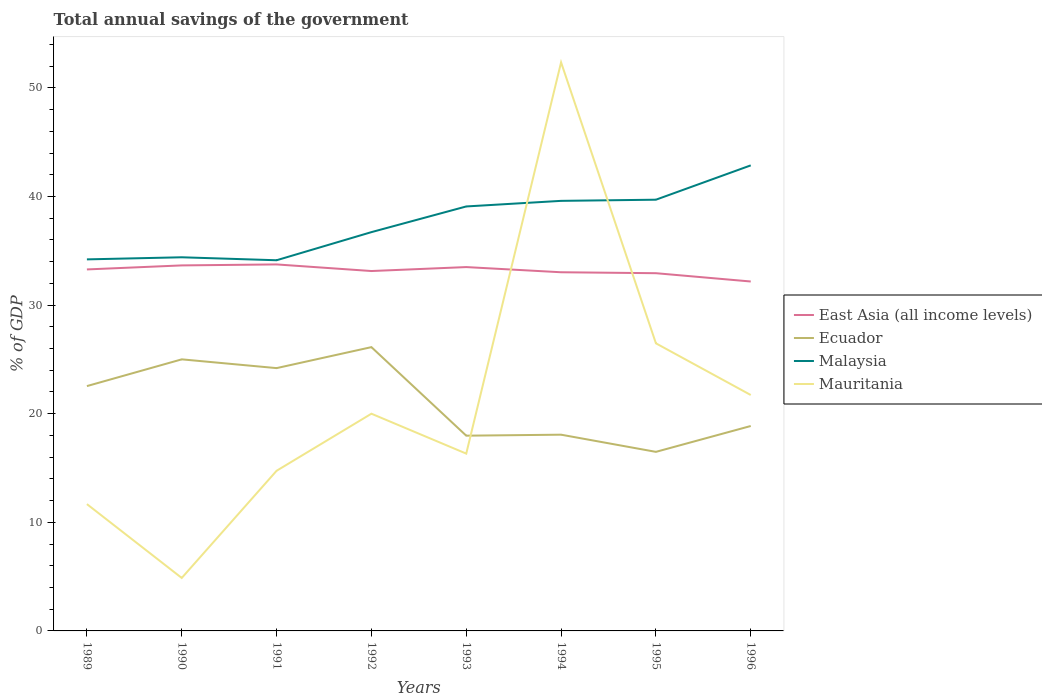How many different coloured lines are there?
Ensure brevity in your answer.  4. Does the line corresponding to Ecuador intersect with the line corresponding to Mauritania?
Offer a very short reply. Yes. Is the number of lines equal to the number of legend labels?
Provide a succinct answer. Yes. Across all years, what is the maximum total annual savings of the government in Malaysia?
Your answer should be very brief. 34.13. In which year was the total annual savings of the government in Malaysia maximum?
Ensure brevity in your answer.  1991. What is the total total annual savings of the government in Mauritania in the graph?
Give a very brief answer. 3.67. What is the difference between the highest and the second highest total annual savings of the government in Ecuador?
Your response must be concise. 9.64. What is the difference between the highest and the lowest total annual savings of the government in East Asia (all income levels)?
Your response must be concise. 4. Is the total annual savings of the government in Malaysia strictly greater than the total annual savings of the government in Ecuador over the years?
Offer a very short reply. No. How many lines are there?
Keep it short and to the point. 4. Where does the legend appear in the graph?
Provide a short and direct response. Center right. How many legend labels are there?
Offer a terse response. 4. How are the legend labels stacked?
Give a very brief answer. Vertical. What is the title of the graph?
Offer a very short reply. Total annual savings of the government. Does "Oman" appear as one of the legend labels in the graph?
Keep it short and to the point. No. What is the label or title of the X-axis?
Your response must be concise. Years. What is the label or title of the Y-axis?
Keep it short and to the point. % of GDP. What is the % of GDP of East Asia (all income levels) in 1989?
Keep it short and to the point. 33.29. What is the % of GDP in Ecuador in 1989?
Give a very brief answer. 22.54. What is the % of GDP of Malaysia in 1989?
Your answer should be very brief. 34.21. What is the % of GDP of Mauritania in 1989?
Offer a very short reply. 11.68. What is the % of GDP of East Asia (all income levels) in 1990?
Ensure brevity in your answer.  33.66. What is the % of GDP of Ecuador in 1990?
Give a very brief answer. 25.01. What is the % of GDP of Malaysia in 1990?
Make the answer very short. 34.4. What is the % of GDP of Mauritania in 1990?
Provide a succinct answer. 4.88. What is the % of GDP of East Asia (all income levels) in 1991?
Keep it short and to the point. 33.75. What is the % of GDP of Ecuador in 1991?
Your answer should be very brief. 24.2. What is the % of GDP in Malaysia in 1991?
Your answer should be compact. 34.13. What is the % of GDP of Mauritania in 1991?
Give a very brief answer. 14.74. What is the % of GDP of East Asia (all income levels) in 1992?
Keep it short and to the point. 33.14. What is the % of GDP in Ecuador in 1992?
Your response must be concise. 26.13. What is the % of GDP in Malaysia in 1992?
Provide a short and direct response. 36.72. What is the % of GDP in Mauritania in 1992?
Offer a very short reply. 20. What is the % of GDP of East Asia (all income levels) in 1993?
Offer a very short reply. 33.5. What is the % of GDP of Ecuador in 1993?
Make the answer very short. 17.98. What is the % of GDP in Malaysia in 1993?
Offer a terse response. 39.08. What is the % of GDP of Mauritania in 1993?
Ensure brevity in your answer.  16.33. What is the % of GDP of East Asia (all income levels) in 1994?
Make the answer very short. 33.02. What is the % of GDP in Ecuador in 1994?
Keep it short and to the point. 18.07. What is the % of GDP in Malaysia in 1994?
Ensure brevity in your answer.  39.6. What is the % of GDP of Mauritania in 1994?
Ensure brevity in your answer.  52.35. What is the % of GDP of East Asia (all income levels) in 1995?
Your response must be concise. 32.94. What is the % of GDP in Ecuador in 1995?
Provide a succinct answer. 16.49. What is the % of GDP of Malaysia in 1995?
Your answer should be compact. 39.71. What is the % of GDP of Mauritania in 1995?
Provide a succinct answer. 26.48. What is the % of GDP in East Asia (all income levels) in 1996?
Ensure brevity in your answer.  32.17. What is the % of GDP of Ecuador in 1996?
Your answer should be very brief. 18.87. What is the % of GDP of Malaysia in 1996?
Give a very brief answer. 42.87. What is the % of GDP of Mauritania in 1996?
Give a very brief answer. 21.72. Across all years, what is the maximum % of GDP in East Asia (all income levels)?
Your response must be concise. 33.75. Across all years, what is the maximum % of GDP of Ecuador?
Your response must be concise. 26.13. Across all years, what is the maximum % of GDP in Malaysia?
Keep it short and to the point. 42.87. Across all years, what is the maximum % of GDP in Mauritania?
Ensure brevity in your answer.  52.35. Across all years, what is the minimum % of GDP in East Asia (all income levels)?
Make the answer very short. 32.17. Across all years, what is the minimum % of GDP in Ecuador?
Your answer should be compact. 16.49. Across all years, what is the minimum % of GDP in Malaysia?
Your response must be concise. 34.13. Across all years, what is the minimum % of GDP of Mauritania?
Make the answer very short. 4.88. What is the total % of GDP in East Asia (all income levels) in the graph?
Offer a very short reply. 265.46. What is the total % of GDP in Ecuador in the graph?
Provide a short and direct response. 169.28. What is the total % of GDP of Malaysia in the graph?
Provide a short and direct response. 300.72. What is the total % of GDP of Mauritania in the graph?
Provide a short and direct response. 168.18. What is the difference between the % of GDP of East Asia (all income levels) in 1989 and that in 1990?
Offer a very short reply. -0.37. What is the difference between the % of GDP in Ecuador in 1989 and that in 1990?
Your answer should be very brief. -2.46. What is the difference between the % of GDP in Malaysia in 1989 and that in 1990?
Ensure brevity in your answer.  -0.19. What is the difference between the % of GDP of Mauritania in 1989 and that in 1990?
Your response must be concise. 6.8. What is the difference between the % of GDP in East Asia (all income levels) in 1989 and that in 1991?
Provide a short and direct response. -0.46. What is the difference between the % of GDP in Ecuador in 1989 and that in 1991?
Provide a succinct answer. -1.65. What is the difference between the % of GDP of Malaysia in 1989 and that in 1991?
Keep it short and to the point. 0.08. What is the difference between the % of GDP of Mauritania in 1989 and that in 1991?
Give a very brief answer. -3.07. What is the difference between the % of GDP of East Asia (all income levels) in 1989 and that in 1992?
Ensure brevity in your answer.  0.15. What is the difference between the % of GDP in Ecuador in 1989 and that in 1992?
Your answer should be compact. -3.59. What is the difference between the % of GDP in Malaysia in 1989 and that in 1992?
Provide a succinct answer. -2.51. What is the difference between the % of GDP of Mauritania in 1989 and that in 1992?
Keep it short and to the point. -8.32. What is the difference between the % of GDP in East Asia (all income levels) in 1989 and that in 1993?
Provide a succinct answer. -0.22. What is the difference between the % of GDP in Ecuador in 1989 and that in 1993?
Provide a succinct answer. 4.57. What is the difference between the % of GDP of Malaysia in 1989 and that in 1993?
Offer a terse response. -4.87. What is the difference between the % of GDP in Mauritania in 1989 and that in 1993?
Offer a terse response. -4.65. What is the difference between the % of GDP of East Asia (all income levels) in 1989 and that in 1994?
Give a very brief answer. 0.26. What is the difference between the % of GDP in Ecuador in 1989 and that in 1994?
Keep it short and to the point. 4.47. What is the difference between the % of GDP in Malaysia in 1989 and that in 1994?
Offer a terse response. -5.39. What is the difference between the % of GDP of Mauritania in 1989 and that in 1994?
Your answer should be very brief. -40.68. What is the difference between the % of GDP in East Asia (all income levels) in 1989 and that in 1995?
Your response must be concise. 0.35. What is the difference between the % of GDP in Ecuador in 1989 and that in 1995?
Your response must be concise. 6.06. What is the difference between the % of GDP in Malaysia in 1989 and that in 1995?
Provide a succinct answer. -5.49. What is the difference between the % of GDP of Mauritania in 1989 and that in 1995?
Give a very brief answer. -14.8. What is the difference between the % of GDP in East Asia (all income levels) in 1989 and that in 1996?
Your response must be concise. 1.11. What is the difference between the % of GDP of Ecuador in 1989 and that in 1996?
Provide a short and direct response. 3.67. What is the difference between the % of GDP in Malaysia in 1989 and that in 1996?
Provide a succinct answer. -8.65. What is the difference between the % of GDP of Mauritania in 1989 and that in 1996?
Your response must be concise. -10.05. What is the difference between the % of GDP of East Asia (all income levels) in 1990 and that in 1991?
Provide a succinct answer. -0.09. What is the difference between the % of GDP in Ecuador in 1990 and that in 1991?
Keep it short and to the point. 0.81. What is the difference between the % of GDP of Malaysia in 1990 and that in 1991?
Offer a terse response. 0.27. What is the difference between the % of GDP in Mauritania in 1990 and that in 1991?
Your response must be concise. -9.87. What is the difference between the % of GDP of East Asia (all income levels) in 1990 and that in 1992?
Ensure brevity in your answer.  0.52. What is the difference between the % of GDP in Ecuador in 1990 and that in 1992?
Offer a terse response. -1.13. What is the difference between the % of GDP in Malaysia in 1990 and that in 1992?
Your answer should be very brief. -2.31. What is the difference between the % of GDP in Mauritania in 1990 and that in 1992?
Offer a terse response. -15.12. What is the difference between the % of GDP in East Asia (all income levels) in 1990 and that in 1993?
Your response must be concise. 0.15. What is the difference between the % of GDP in Ecuador in 1990 and that in 1993?
Offer a terse response. 7.03. What is the difference between the % of GDP in Malaysia in 1990 and that in 1993?
Offer a very short reply. -4.68. What is the difference between the % of GDP in Mauritania in 1990 and that in 1993?
Provide a short and direct response. -11.45. What is the difference between the % of GDP of East Asia (all income levels) in 1990 and that in 1994?
Your response must be concise. 0.63. What is the difference between the % of GDP of Ecuador in 1990 and that in 1994?
Make the answer very short. 6.94. What is the difference between the % of GDP of Malaysia in 1990 and that in 1994?
Offer a terse response. -5.19. What is the difference between the % of GDP in Mauritania in 1990 and that in 1994?
Your response must be concise. -47.48. What is the difference between the % of GDP in East Asia (all income levels) in 1990 and that in 1995?
Your answer should be very brief. 0.72. What is the difference between the % of GDP of Ecuador in 1990 and that in 1995?
Your answer should be compact. 8.52. What is the difference between the % of GDP of Malaysia in 1990 and that in 1995?
Ensure brevity in your answer.  -5.3. What is the difference between the % of GDP of Mauritania in 1990 and that in 1995?
Your response must be concise. -21.6. What is the difference between the % of GDP in East Asia (all income levels) in 1990 and that in 1996?
Make the answer very short. 1.48. What is the difference between the % of GDP of Ecuador in 1990 and that in 1996?
Provide a succinct answer. 6.14. What is the difference between the % of GDP of Malaysia in 1990 and that in 1996?
Give a very brief answer. -8.46. What is the difference between the % of GDP of Mauritania in 1990 and that in 1996?
Your response must be concise. -16.85. What is the difference between the % of GDP of East Asia (all income levels) in 1991 and that in 1992?
Make the answer very short. 0.61. What is the difference between the % of GDP of Ecuador in 1991 and that in 1992?
Provide a succinct answer. -1.93. What is the difference between the % of GDP of Malaysia in 1991 and that in 1992?
Make the answer very short. -2.59. What is the difference between the % of GDP in Mauritania in 1991 and that in 1992?
Keep it short and to the point. -5.26. What is the difference between the % of GDP of East Asia (all income levels) in 1991 and that in 1993?
Give a very brief answer. 0.24. What is the difference between the % of GDP in Ecuador in 1991 and that in 1993?
Provide a succinct answer. 6.22. What is the difference between the % of GDP in Malaysia in 1991 and that in 1993?
Provide a succinct answer. -4.95. What is the difference between the % of GDP in Mauritania in 1991 and that in 1993?
Your answer should be very brief. -1.58. What is the difference between the % of GDP of East Asia (all income levels) in 1991 and that in 1994?
Provide a succinct answer. 0.72. What is the difference between the % of GDP of Ecuador in 1991 and that in 1994?
Keep it short and to the point. 6.13. What is the difference between the % of GDP of Malaysia in 1991 and that in 1994?
Give a very brief answer. -5.47. What is the difference between the % of GDP in Mauritania in 1991 and that in 1994?
Ensure brevity in your answer.  -37.61. What is the difference between the % of GDP of East Asia (all income levels) in 1991 and that in 1995?
Offer a terse response. 0.81. What is the difference between the % of GDP of Ecuador in 1991 and that in 1995?
Give a very brief answer. 7.71. What is the difference between the % of GDP of Malaysia in 1991 and that in 1995?
Offer a terse response. -5.57. What is the difference between the % of GDP of Mauritania in 1991 and that in 1995?
Give a very brief answer. -11.74. What is the difference between the % of GDP of East Asia (all income levels) in 1991 and that in 1996?
Provide a short and direct response. 1.57. What is the difference between the % of GDP in Ecuador in 1991 and that in 1996?
Your response must be concise. 5.33. What is the difference between the % of GDP in Malaysia in 1991 and that in 1996?
Make the answer very short. -8.74. What is the difference between the % of GDP in Mauritania in 1991 and that in 1996?
Ensure brevity in your answer.  -6.98. What is the difference between the % of GDP in East Asia (all income levels) in 1992 and that in 1993?
Keep it short and to the point. -0.36. What is the difference between the % of GDP in Ecuador in 1992 and that in 1993?
Provide a succinct answer. 8.15. What is the difference between the % of GDP in Malaysia in 1992 and that in 1993?
Your answer should be compact. -2.36. What is the difference between the % of GDP in Mauritania in 1992 and that in 1993?
Your answer should be compact. 3.67. What is the difference between the % of GDP in East Asia (all income levels) in 1992 and that in 1994?
Give a very brief answer. 0.11. What is the difference between the % of GDP in Ecuador in 1992 and that in 1994?
Make the answer very short. 8.06. What is the difference between the % of GDP of Malaysia in 1992 and that in 1994?
Provide a succinct answer. -2.88. What is the difference between the % of GDP of Mauritania in 1992 and that in 1994?
Keep it short and to the point. -32.35. What is the difference between the % of GDP in East Asia (all income levels) in 1992 and that in 1995?
Your response must be concise. 0.2. What is the difference between the % of GDP of Ecuador in 1992 and that in 1995?
Provide a succinct answer. 9.64. What is the difference between the % of GDP in Malaysia in 1992 and that in 1995?
Your answer should be compact. -2.99. What is the difference between the % of GDP of Mauritania in 1992 and that in 1995?
Keep it short and to the point. -6.48. What is the difference between the % of GDP of East Asia (all income levels) in 1992 and that in 1996?
Ensure brevity in your answer.  0.96. What is the difference between the % of GDP in Ecuador in 1992 and that in 1996?
Provide a succinct answer. 7.26. What is the difference between the % of GDP in Malaysia in 1992 and that in 1996?
Offer a very short reply. -6.15. What is the difference between the % of GDP in Mauritania in 1992 and that in 1996?
Your answer should be very brief. -1.72. What is the difference between the % of GDP of East Asia (all income levels) in 1993 and that in 1994?
Provide a succinct answer. 0.48. What is the difference between the % of GDP in Ecuador in 1993 and that in 1994?
Your response must be concise. -0.09. What is the difference between the % of GDP in Malaysia in 1993 and that in 1994?
Make the answer very short. -0.51. What is the difference between the % of GDP of Mauritania in 1993 and that in 1994?
Your answer should be compact. -36.03. What is the difference between the % of GDP of East Asia (all income levels) in 1993 and that in 1995?
Offer a very short reply. 0.56. What is the difference between the % of GDP of Ecuador in 1993 and that in 1995?
Provide a short and direct response. 1.49. What is the difference between the % of GDP of Malaysia in 1993 and that in 1995?
Provide a short and direct response. -0.62. What is the difference between the % of GDP of Mauritania in 1993 and that in 1995?
Your answer should be compact. -10.16. What is the difference between the % of GDP in East Asia (all income levels) in 1993 and that in 1996?
Make the answer very short. 1.33. What is the difference between the % of GDP of Ecuador in 1993 and that in 1996?
Offer a very short reply. -0.89. What is the difference between the % of GDP of Malaysia in 1993 and that in 1996?
Ensure brevity in your answer.  -3.78. What is the difference between the % of GDP in Mauritania in 1993 and that in 1996?
Provide a succinct answer. -5.4. What is the difference between the % of GDP in East Asia (all income levels) in 1994 and that in 1995?
Your answer should be very brief. 0.09. What is the difference between the % of GDP of Ecuador in 1994 and that in 1995?
Provide a short and direct response. 1.58. What is the difference between the % of GDP of Malaysia in 1994 and that in 1995?
Your answer should be very brief. -0.11. What is the difference between the % of GDP in Mauritania in 1994 and that in 1995?
Provide a succinct answer. 25.87. What is the difference between the % of GDP of East Asia (all income levels) in 1994 and that in 1996?
Your answer should be compact. 0.85. What is the difference between the % of GDP in Ecuador in 1994 and that in 1996?
Make the answer very short. -0.8. What is the difference between the % of GDP of Malaysia in 1994 and that in 1996?
Keep it short and to the point. -3.27. What is the difference between the % of GDP of Mauritania in 1994 and that in 1996?
Your answer should be very brief. 30.63. What is the difference between the % of GDP in East Asia (all income levels) in 1995 and that in 1996?
Your answer should be compact. 0.76. What is the difference between the % of GDP of Ecuador in 1995 and that in 1996?
Ensure brevity in your answer.  -2.38. What is the difference between the % of GDP of Malaysia in 1995 and that in 1996?
Give a very brief answer. -3.16. What is the difference between the % of GDP in Mauritania in 1995 and that in 1996?
Make the answer very short. 4.76. What is the difference between the % of GDP of East Asia (all income levels) in 1989 and the % of GDP of Ecuador in 1990?
Your response must be concise. 8.28. What is the difference between the % of GDP of East Asia (all income levels) in 1989 and the % of GDP of Malaysia in 1990?
Offer a very short reply. -1.12. What is the difference between the % of GDP of East Asia (all income levels) in 1989 and the % of GDP of Mauritania in 1990?
Your response must be concise. 28.41. What is the difference between the % of GDP in Ecuador in 1989 and the % of GDP in Malaysia in 1990?
Make the answer very short. -11.86. What is the difference between the % of GDP of Ecuador in 1989 and the % of GDP of Mauritania in 1990?
Your answer should be compact. 17.67. What is the difference between the % of GDP in Malaysia in 1989 and the % of GDP in Mauritania in 1990?
Make the answer very short. 29.34. What is the difference between the % of GDP of East Asia (all income levels) in 1989 and the % of GDP of Ecuador in 1991?
Provide a short and direct response. 9.09. What is the difference between the % of GDP of East Asia (all income levels) in 1989 and the % of GDP of Malaysia in 1991?
Keep it short and to the point. -0.85. What is the difference between the % of GDP in East Asia (all income levels) in 1989 and the % of GDP in Mauritania in 1991?
Offer a terse response. 18.54. What is the difference between the % of GDP in Ecuador in 1989 and the % of GDP in Malaysia in 1991?
Give a very brief answer. -11.59. What is the difference between the % of GDP in Ecuador in 1989 and the % of GDP in Mauritania in 1991?
Your answer should be compact. 7.8. What is the difference between the % of GDP in Malaysia in 1989 and the % of GDP in Mauritania in 1991?
Ensure brevity in your answer.  19.47. What is the difference between the % of GDP of East Asia (all income levels) in 1989 and the % of GDP of Ecuador in 1992?
Your response must be concise. 7.15. What is the difference between the % of GDP of East Asia (all income levels) in 1989 and the % of GDP of Malaysia in 1992?
Your answer should be very brief. -3.43. What is the difference between the % of GDP in East Asia (all income levels) in 1989 and the % of GDP in Mauritania in 1992?
Your response must be concise. 13.28. What is the difference between the % of GDP of Ecuador in 1989 and the % of GDP of Malaysia in 1992?
Offer a terse response. -14.18. What is the difference between the % of GDP of Ecuador in 1989 and the % of GDP of Mauritania in 1992?
Make the answer very short. 2.54. What is the difference between the % of GDP in Malaysia in 1989 and the % of GDP in Mauritania in 1992?
Your answer should be compact. 14.21. What is the difference between the % of GDP of East Asia (all income levels) in 1989 and the % of GDP of Ecuador in 1993?
Keep it short and to the point. 15.31. What is the difference between the % of GDP in East Asia (all income levels) in 1989 and the % of GDP in Malaysia in 1993?
Give a very brief answer. -5.8. What is the difference between the % of GDP in East Asia (all income levels) in 1989 and the % of GDP in Mauritania in 1993?
Offer a terse response. 16.96. What is the difference between the % of GDP in Ecuador in 1989 and the % of GDP in Malaysia in 1993?
Offer a very short reply. -16.54. What is the difference between the % of GDP in Ecuador in 1989 and the % of GDP in Mauritania in 1993?
Your answer should be very brief. 6.22. What is the difference between the % of GDP of Malaysia in 1989 and the % of GDP of Mauritania in 1993?
Provide a short and direct response. 17.89. What is the difference between the % of GDP of East Asia (all income levels) in 1989 and the % of GDP of Ecuador in 1994?
Your response must be concise. 15.22. What is the difference between the % of GDP in East Asia (all income levels) in 1989 and the % of GDP in Malaysia in 1994?
Your answer should be very brief. -6.31. What is the difference between the % of GDP in East Asia (all income levels) in 1989 and the % of GDP in Mauritania in 1994?
Keep it short and to the point. -19.07. What is the difference between the % of GDP of Ecuador in 1989 and the % of GDP of Malaysia in 1994?
Provide a short and direct response. -17.06. What is the difference between the % of GDP of Ecuador in 1989 and the % of GDP of Mauritania in 1994?
Keep it short and to the point. -29.81. What is the difference between the % of GDP of Malaysia in 1989 and the % of GDP of Mauritania in 1994?
Your answer should be compact. -18.14. What is the difference between the % of GDP in East Asia (all income levels) in 1989 and the % of GDP in Ecuador in 1995?
Keep it short and to the point. 16.8. What is the difference between the % of GDP of East Asia (all income levels) in 1989 and the % of GDP of Malaysia in 1995?
Make the answer very short. -6.42. What is the difference between the % of GDP in East Asia (all income levels) in 1989 and the % of GDP in Mauritania in 1995?
Provide a short and direct response. 6.8. What is the difference between the % of GDP in Ecuador in 1989 and the % of GDP in Malaysia in 1995?
Your answer should be very brief. -17.16. What is the difference between the % of GDP of Ecuador in 1989 and the % of GDP of Mauritania in 1995?
Your answer should be very brief. -3.94. What is the difference between the % of GDP of Malaysia in 1989 and the % of GDP of Mauritania in 1995?
Your answer should be compact. 7.73. What is the difference between the % of GDP of East Asia (all income levels) in 1989 and the % of GDP of Ecuador in 1996?
Provide a short and direct response. 14.42. What is the difference between the % of GDP in East Asia (all income levels) in 1989 and the % of GDP in Malaysia in 1996?
Provide a succinct answer. -9.58. What is the difference between the % of GDP in East Asia (all income levels) in 1989 and the % of GDP in Mauritania in 1996?
Provide a succinct answer. 11.56. What is the difference between the % of GDP in Ecuador in 1989 and the % of GDP in Malaysia in 1996?
Provide a succinct answer. -20.32. What is the difference between the % of GDP in Ecuador in 1989 and the % of GDP in Mauritania in 1996?
Make the answer very short. 0.82. What is the difference between the % of GDP in Malaysia in 1989 and the % of GDP in Mauritania in 1996?
Offer a terse response. 12.49. What is the difference between the % of GDP in East Asia (all income levels) in 1990 and the % of GDP in Ecuador in 1991?
Your answer should be very brief. 9.46. What is the difference between the % of GDP of East Asia (all income levels) in 1990 and the % of GDP of Malaysia in 1991?
Keep it short and to the point. -0.47. What is the difference between the % of GDP of East Asia (all income levels) in 1990 and the % of GDP of Mauritania in 1991?
Give a very brief answer. 18.91. What is the difference between the % of GDP of Ecuador in 1990 and the % of GDP of Malaysia in 1991?
Provide a succinct answer. -9.12. What is the difference between the % of GDP of Ecuador in 1990 and the % of GDP of Mauritania in 1991?
Your answer should be compact. 10.26. What is the difference between the % of GDP in Malaysia in 1990 and the % of GDP in Mauritania in 1991?
Provide a short and direct response. 19.66. What is the difference between the % of GDP of East Asia (all income levels) in 1990 and the % of GDP of Ecuador in 1992?
Your answer should be very brief. 7.52. What is the difference between the % of GDP in East Asia (all income levels) in 1990 and the % of GDP in Malaysia in 1992?
Provide a succinct answer. -3.06. What is the difference between the % of GDP in East Asia (all income levels) in 1990 and the % of GDP in Mauritania in 1992?
Give a very brief answer. 13.66. What is the difference between the % of GDP of Ecuador in 1990 and the % of GDP of Malaysia in 1992?
Your response must be concise. -11.71. What is the difference between the % of GDP in Ecuador in 1990 and the % of GDP in Mauritania in 1992?
Ensure brevity in your answer.  5.01. What is the difference between the % of GDP of Malaysia in 1990 and the % of GDP of Mauritania in 1992?
Offer a terse response. 14.4. What is the difference between the % of GDP in East Asia (all income levels) in 1990 and the % of GDP in Ecuador in 1993?
Offer a very short reply. 15.68. What is the difference between the % of GDP in East Asia (all income levels) in 1990 and the % of GDP in Malaysia in 1993?
Offer a terse response. -5.43. What is the difference between the % of GDP in East Asia (all income levels) in 1990 and the % of GDP in Mauritania in 1993?
Give a very brief answer. 17.33. What is the difference between the % of GDP of Ecuador in 1990 and the % of GDP of Malaysia in 1993?
Your answer should be compact. -14.08. What is the difference between the % of GDP of Ecuador in 1990 and the % of GDP of Mauritania in 1993?
Give a very brief answer. 8.68. What is the difference between the % of GDP in Malaysia in 1990 and the % of GDP in Mauritania in 1993?
Offer a terse response. 18.08. What is the difference between the % of GDP in East Asia (all income levels) in 1990 and the % of GDP in Ecuador in 1994?
Give a very brief answer. 15.59. What is the difference between the % of GDP of East Asia (all income levels) in 1990 and the % of GDP of Malaysia in 1994?
Give a very brief answer. -5.94. What is the difference between the % of GDP of East Asia (all income levels) in 1990 and the % of GDP of Mauritania in 1994?
Provide a short and direct response. -18.7. What is the difference between the % of GDP of Ecuador in 1990 and the % of GDP of Malaysia in 1994?
Provide a short and direct response. -14.59. What is the difference between the % of GDP in Ecuador in 1990 and the % of GDP in Mauritania in 1994?
Offer a terse response. -27.35. What is the difference between the % of GDP in Malaysia in 1990 and the % of GDP in Mauritania in 1994?
Provide a succinct answer. -17.95. What is the difference between the % of GDP in East Asia (all income levels) in 1990 and the % of GDP in Ecuador in 1995?
Keep it short and to the point. 17.17. What is the difference between the % of GDP of East Asia (all income levels) in 1990 and the % of GDP of Malaysia in 1995?
Provide a succinct answer. -6.05. What is the difference between the % of GDP in East Asia (all income levels) in 1990 and the % of GDP in Mauritania in 1995?
Offer a very short reply. 7.17. What is the difference between the % of GDP in Ecuador in 1990 and the % of GDP in Malaysia in 1995?
Provide a succinct answer. -14.7. What is the difference between the % of GDP in Ecuador in 1990 and the % of GDP in Mauritania in 1995?
Ensure brevity in your answer.  -1.48. What is the difference between the % of GDP in Malaysia in 1990 and the % of GDP in Mauritania in 1995?
Your answer should be very brief. 7.92. What is the difference between the % of GDP of East Asia (all income levels) in 1990 and the % of GDP of Ecuador in 1996?
Offer a very short reply. 14.79. What is the difference between the % of GDP of East Asia (all income levels) in 1990 and the % of GDP of Malaysia in 1996?
Keep it short and to the point. -9.21. What is the difference between the % of GDP in East Asia (all income levels) in 1990 and the % of GDP in Mauritania in 1996?
Make the answer very short. 11.93. What is the difference between the % of GDP of Ecuador in 1990 and the % of GDP of Malaysia in 1996?
Give a very brief answer. -17.86. What is the difference between the % of GDP of Ecuador in 1990 and the % of GDP of Mauritania in 1996?
Provide a short and direct response. 3.28. What is the difference between the % of GDP of Malaysia in 1990 and the % of GDP of Mauritania in 1996?
Your answer should be very brief. 12.68. What is the difference between the % of GDP of East Asia (all income levels) in 1991 and the % of GDP of Ecuador in 1992?
Offer a very short reply. 7.62. What is the difference between the % of GDP in East Asia (all income levels) in 1991 and the % of GDP in Malaysia in 1992?
Provide a short and direct response. -2.97. What is the difference between the % of GDP in East Asia (all income levels) in 1991 and the % of GDP in Mauritania in 1992?
Provide a succinct answer. 13.75. What is the difference between the % of GDP in Ecuador in 1991 and the % of GDP in Malaysia in 1992?
Your response must be concise. -12.52. What is the difference between the % of GDP of Ecuador in 1991 and the % of GDP of Mauritania in 1992?
Provide a succinct answer. 4.2. What is the difference between the % of GDP in Malaysia in 1991 and the % of GDP in Mauritania in 1992?
Provide a short and direct response. 14.13. What is the difference between the % of GDP in East Asia (all income levels) in 1991 and the % of GDP in Ecuador in 1993?
Provide a short and direct response. 15.77. What is the difference between the % of GDP in East Asia (all income levels) in 1991 and the % of GDP in Malaysia in 1993?
Offer a terse response. -5.34. What is the difference between the % of GDP in East Asia (all income levels) in 1991 and the % of GDP in Mauritania in 1993?
Give a very brief answer. 17.42. What is the difference between the % of GDP of Ecuador in 1991 and the % of GDP of Malaysia in 1993?
Make the answer very short. -14.89. What is the difference between the % of GDP in Ecuador in 1991 and the % of GDP in Mauritania in 1993?
Offer a terse response. 7.87. What is the difference between the % of GDP in Malaysia in 1991 and the % of GDP in Mauritania in 1993?
Provide a short and direct response. 17.8. What is the difference between the % of GDP of East Asia (all income levels) in 1991 and the % of GDP of Ecuador in 1994?
Ensure brevity in your answer.  15.68. What is the difference between the % of GDP of East Asia (all income levels) in 1991 and the % of GDP of Malaysia in 1994?
Provide a short and direct response. -5.85. What is the difference between the % of GDP in East Asia (all income levels) in 1991 and the % of GDP in Mauritania in 1994?
Provide a short and direct response. -18.61. What is the difference between the % of GDP of Ecuador in 1991 and the % of GDP of Malaysia in 1994?
Provide a short and direct response. -15.4. What is the difference between the % of GDP in Ecuador in 1991 and the % of GDP in Mauritania in 1994?
Ensure brevity in your answer.  -28.15. What is the difference between the % of GDP in Malaysia in 1991 and the % of GDP in Mauritania in 1994?
Your answer should be compact. -18.22. What is the difference between the % of GDP in East Asia (all income levels) in 1991 and the % of GDP in Ecuador in 1995?
Keep it short and to the point. 17.26. What is the difference between the % of GDP in East Asia (all income levels) in 1991 and the % of GDP in Malaysia in 1995?
Keep it short and to the point. -5.96. What is the difference between the % of GDP in East Asia (all income levels) in 1991 and the % of GDP in Mauritania in 1995?
Ensure brevity in your answer.  7.27. What is the difference between the % of GDP of Ecuador in 1991 and the % of GDP of Malaysia in 1995?
Your response must be concise. -15.51. What is the difference between the % of GDP of Ecuador in 1991 and the % of GDP of Mauritania in 1995?
Offer a very short reply. -2.28. What is the difference between the % of GDP of Malaysia in 1991 and the % of GDP of Mauritania in 1995?
Offer a very short reply. 7.65. What is the difference between the % of GDP of East Asia (all income levels) in 1991 and the % of GDP of Ecuador in 1996?
Offer a terse response. 14.88. What is the difference between the % of GDP in East Asia (all income levels) in 1991 and the % of GDP in Malaysia in 1996?
Offer a very short reply. -9.12. What is the difference between the % of GDP in East Asia (all income levels) in 1991 and the % of GDP in Mauritania in 1996?
Offer a terse response. 12.02. What is the difference between the % of GDP in Ecuador in 1991 and the % of GDP in Malaysia in 1996?
Offer a very short reply. -18.67. What is the difference between the % of GDP in Ecuador in 1991 and the % of GDP in Mauritania in 1996?
Ensure brevity in your answer.  2.48. What is the difference between the % of GDP of Malaysia in 1991 and the % of GDP of Mauritania in 1996?
Offer a very short reply. 12.41. What is the difference between the % of GDP of East Asia (all income levels) in 1992 and the % of GDP of Ecuador in 1993?
Ensure brevity in your answer.  15.16. What is the difference between the % of GDP of East Asia (all income levels) in 1992 and the % of GDP of Malaysia in 1993?
Provide a succinct answer. -5.95. What is the difference between the % of GDP in East Asia (all income levels) in 1992 and the % of GDP in Mauritania in 1993?
Your answer should be very brief. 16.81. What is the difference between the % of GDP in Ecuador in 1992 and the % of GDP in Malaysia in 1993?
Offer a very short reply. -12.95. What is the difference between the % of GDP in Ecuador in 1992 and the % of GDP in Mauritania in 1993?
Provide a short and direct response. 9.8. What is the difference between the % of GDP of Malaysia in 1992 and the % of GDP of Mauritania in 1993?
Your answer should be compact. 20.39. What is the difference between the % of GDP of East Asia (all income levels) in 1992 and the % of GDP of Ecuador in 1994?
Offer a very short reply. 15.07. What is the difference between the % of GDP of East Asia (all income levels) in 1992 and the % of GDP of Malaysia in 1994?
Give a very brief answer. -6.46. What is the difference between the % of GDP in East Asia (all income levels) in 1992 and the % of GDP in Mauritania in 1994?
Your response must be concise. -19.21. What is the difference between the % of GDP of Ecuador in 1992 and the % of GDP of Malaysia in 1994?
Your answer should be very brief. -13.47. What is the difference between the % of GDP of Ecuador in 1992 and the % of GDP of Mauritania in 1994?
Give a very brief answer. -26.22. What is the difference between the % of GDP in Malaysia in 1992 and the % of GDP in Mauritania in 1994?
Make the answer very short. -15.63. What is the difference between the % of GDP in East Asia (all income levels) in 1992 and the % of GDP in Ecuador in 1995?
Provide a succinct answer. 16.65. What is the difference between the % of GDP of East Asia (all income levels) in 1992 and the % of GDP of Malaysia in 1995?
Ensure brevity in your answer.  -6.57. What is the difference between the % of GDP of East Asia (all income levels) in 1992 and the % of GDP of Mauritania in 1995?
Your answer should be compact. 6.66. What is the difference between the % of GDP of Ecuador in 1992 and the % of GDP of Malaysia in 1995?
Give a very brief answer. -13.57. What is the difference between the % of GDP of Ecuador in 1992 and the % of GDP of Mauritania in 1995?
Provide a succinct answer. -0.35. What is the difference between the % of GDP in Malaysia in 1992 and the % of GDP in Mauritania in 1995?
Your answer should be compact. 10.24. What is the difference between the % of GDP in East Asia (all income levels) in 1992 and the % of GDP in Ecuador in 1996?
Offer a very short reply. 14.27. What is the difference between the % of GDP in East Asia (all income levels) in 1992 and the % of GDP in Malaysia in 1996?
Your response must be concise. -9.73. What is the difference between the % of GDP in East Asia (all income levels) in 1992 and the % of GDP in Mauritania in 1996?
Ensure brevity in your answer.  11.42. What is the difference between the % of GDP in Ecuador in 1992 and the % of GDP in Malaysia in 1996?
Give a very brief answer. -16.73. What is the difference between the % of GDP of Ecuador in 1992 and the % of GDP of Mauritania in 1996?
Offer a terse response. 4.41. What is the difference between the % of GDP of Malaysia in 1992 and the % of GDP of Mauritania in 1996?
Your answer should be very brief. 15. What is the difference between the % of GDP in East Asia (all income levels) in 1993 and the % of GDP in Ecuador in 1994?
Ensure brevity in your answer.  15.43. What is the difference between the % of GDP in East Asia (all income levels) in 1993 and the % of GDP in Malaysia in 1994?
Offer a terse response. -6.1. What is the difference between the % of GDP in East Asia (all income levels) in 1993 and the % of GDP in Mauritania in 1994?
Keep it short and to the point. -18.85. What is the difference between the % of GDP of Ecuador in 1993 and the % of GDP of Malaysia in 1994?
Your response must be concise. -21.62. What is the difference between the % of GDP in Ecuador in 1993 and the % of GDP in Mauritania in 1994?
Provide a short and direct response. -34.37. What is the difference between the % of GDP of Malaysia in 1993 and the % of GDP of Mauritania in 1994?
Provide a succinct answer. -13.27. What is the difference between the % of GDP in East Asia (all income levels) in 1993 and the % of GDP in Ecuador in 1995?
Ensure brevity in your answer.  17.01. What is the difference between the % of GDP of East Asia (all income levels) in 1993 and the % of GDP of Malaysia in 1995?
Ensure brevity in your answer.  -6.2. What is the difference between the % of GDP in East Asia (all income levels) in 1993 and the % of GDP in Mauritania in 1995?
Offer a terse response. 7.02. What is the difference between the % of GDP in Ecuador in 1993 and the % of GDP in Malaysia in 1995?
Offer a very short reply. -21.73. What is the difference between the % of GDP in Ecuador in 1993 and the % of GDP in Mauritania in 1995?
Your answer should be compact. -8.5. What is the difference between the % of GDP in Malaysia in 1993 and the % of GDP in Mauritania in 1995?
Offer a very short reply. 12.6. What is the difference between the % of GDP of East Asia (all income levels) in 1993 and the % of GDP of Ecuador in 1996?
Provide a succinct answer. 14.63. What is the difference between the % of GDP in East Asia (all income levels) in 1993 and the % of GDP in Malaysia in 1996?
Offer a very short reply. -9.36. What is the difference between the % of GDP in East Asia (all income levels) in 1993 and the % of GDP in Mauritania in 1996?
Your answer should be very brief. 11.78. What is the difference between the % of GDP in Ecuador in 1993 and the % of GDP in Malaysia in 1996?
Provide a short and direct response. -24.89. What is the difference between the % of GDP in Ecuador in 1993 and the % of GDP in Mauritania in 1996?
Offer a terse response. -3.74. What is the difference between the % of GDP in Malaysia in 1993 and the % of GDP in Mauritania in 1996?
Keep it short and to the point. 17.36. What is the difference between the % of GDP in East Asia (all income levels) in 1994 and the % of GDP in Ecuador in 1995?
Give a very brief answer. 16.54. What is the difference between the % of GDP of East Asia (all income levels) in 1994 and the % of GDP of Malaysia in 1995?
Your answer should be compact. -6.68. What is the difference between the % of GDP in East Asia (all income levels) in 1994 and the % of GDP in Mauritania in 1995?
Offer a terse response. 6.54. What is the difference between the % of GDP of Ecuador in 1994 and the % of GDP of Malaysia in 1995?
Provide a succinct answer. -21.64. What is the difference between the % of GDP in Ecuador in 1994 and the % of GDP in Mauritania in 1995?
Offer a terse response. -8.41. What is the difference between the % of GDP in Malaysia in 1994 and the % of GDP in Mauritania in 1995?
Your answer should be very brief. 13.12. What is the difference between the % of GDP of East Asia (all income levels) in 1994 and the % of GDP of Ecuador in 1996?
Provide a succinct answer. 14.16. What is the difference between the % of GDP in East Asia (all income levels) in 1994 and the % of GDP in Malaysia in 1996?
Your answer should be very brief. -9.84. What is the difference between the % of GDP in East Asia (all income levels) in 1994 and the % of GDP in Mauritania in 1996?
Give a very brief answer. 11.3. What is the difference between the % of GDP of Ecuador in 1994 and the % of GDP of Malaysia in 1996?
Your answer should be very brief. -24.8. What is the difference between the % of GDP in Ecuador in 1994 and the % of GDP in Mauritania in 1996?
Your response must be concise. -3.65. What is the difference between the % of GDP in Malaysia in 1994 and the % of GDP in Mauritania in 1996?
Ensure brevity in your answer.  17.88. What is the difference between the % of GDP of East Asia (all income levels) in 1995 and the % of GDP of Ecuador in 1996?
Provide a short and direct response. 14.07. What is the difference between the % of GDP of East Asia (all income levels) in 1995 and the % of GDP of Malaysia in 1996?
Offer a very short reply. -9.93. What is the difference between the % of GDP of East Asia (all income levels) in 1995 and the % of GDP of Mauritania in 1996?
Offer a very short reply. 11.22. What is the difference between the % of GDP of Ecuador in 1995 and the % of GDP of Malaysia in 1996?
Give a very brief answer. -26.38. What is the difference between the % of GDP in Ecuador in 1995 and the % of GDP in Mauritania in 1996?
Keep it short and to the point. -5.23. What is the difference between the % of GDP in Malaysia in 1995 and the % of GDP in Mauritania in 1996?
Your response must be concise. 17.98. What is the average % of GDP of East Asia (all income levels) per year?
Offer a very short reply. 33.18. What is the average % of GDP in Ecuador per year?
Your response must be concise. 21.16. What is the average % of GDP of Malaysia per year?
Keep it short and to the point. 37.59. What is the average % of GDP of Mauritania per year?
Make the answer very short. 21.02. In the year 1989, what is the difference between the % of GDP in East Asia (all income levels) and % of GDP in Ecuador?
Keep it short and to the point. 10.74. In the year 1989, what is the difference between the % of GDP of East Asia (all income levels) and % of GDP of Malaysia?
Make the answer very short. -0.93. In the year 1989, what is the difference between the % of GDP of East Asia (all income levels) and % of GDP of Mauritania?
Your answer should be very brief. 21.61. In the year 1989, what is the difference between the % of GDP of Ecuador and % of GDP of Malaysia?
Your response must be concise. -11.67. In the year 1989, what is the difference between the % of GDP of Ecuador and % of GDP of Mauritania?
Offer a very short reply. 10.87. In the year 1989, what is the difference between the % of GDP of Malaysia and % of GDP of Mauritania?
Your answer should be very brief. 22.53. In the year 1990, what is the difference between the % of GDP in East Asia (all income levels) and % of GDP in Ecuador?
Provide a succinct answer. 8.65. In the year 1990, what is the difference between the % of GDP of East Asia (all income levels) and % of GDP of Malaysia?
Ensure brevity in your answer.  -0.75. In the year 1990, what is the difference between the % of GDP of East Asia (all income levels) and % of GDP of Mauritania?
Ensure brevity in your answer.  28.78. In the year 1990, what is the difference between the % of GDP of Ecuador and % of GDP of Malaysia?
Keep it short and to the point. -9.4. In the year 1990, what is the difference between the % of GDP in Ecuador and % of GDP in Mauritania?
Give a very brief answer. 20.13. In the year 1990, what is the difference between the % of GDP of Malaysia and % of GDP of Mauritania?
Offer a terse response. 29.53. In the year 1991, what is the difference between the % of GDP in East Asia (all income levels) and % of GDP in Ecuador?
Offer a terse response. 9.55. In the year 1991, what is the difference between the % of GDP of East Asia (all income levels) and % of GDP of Malaysia?
Provide a succinct answer. -0.38. In the year 1991, what is the difference between the % of GDP in East Asia (all income levels) and % of GDP in Mauritania?
Offer a very short reply. 19. In the year 1991, what is the difference between the % of GDP in Ecuador and % of GDP in Malaysia?
Make the answer very short. -9.93. In the year 1991, what is the difference between the % of GDP of Ecuador and % of GDP of Mauritania?
Ensure brevity in your answer.  9.45. In the year 1991, what is the difference between the % of GDP of Malaysia and % of GDP of Mauritania?
Ensure brevity in your answer.  19.39. In the year 1992, what is the difference between the % of GDP of East Asia (all income levels) and % of GDP of Ecuador?
Give a very brief answer. 7.01. In the year 1992, what is the difference between the % of GDP in East Asia (all income levels) and % of GDP in Malaysia?
Your answer should be compact. -3.58. In the year 1992, what is the difference between the % of GDP of East Asia (all income levels) and % of GDP of Mauritania?
Keep it short and to the point. 13.14. In the year 1992, what is the difference between the % of GDP of Ecuador and % of GDP of Malaysia?
Give a very brief answer. -10.59. In the year 1992, what is the difference between the % of GDP in Ecuador and % of GDP in Mauritania?
Provide a succinct answer. 6.13. In the year 1992, what is the difference between the % of GDP in Malaysia and % of GDP in Mauritania?
Your answer should be very brief. 16.72. In the year 1993, what is the difference between the % of GDP in East Asia (all income levels) and % of GDP in Ecuador?
Ensure brevity in your answer.  15.52. In the year 1993, what is the difference between the % of GDP of East Asia (all income levels) and % of GDP of Malaysia?
Provide a short and direct response. -5.58. In the year 1993, what is the difference between the % of GDP in East Asia (all income levels) and % of GDP in Mauritania?
Provide a succinct answer. 17.18. In the year 1993, what is the difference between the % of GDP in Ecuador and % of GDP in Malaysia?
Your answer should be very brief. -21.11. In the year 1993, what is the difference between the % of GDP in Ecuador and % of GDP in Mauritania?
Offer a very short reply. 1.65. In the year 1993, what is the difference between the % of GDP of Malaysia and % of GDP of Mauritania?
Offer a very short reply. 22.76. In the year 1994, what is the difference between the % of GDP of East Asia (all income levels) and % of GDP of Ecuador?
Ensure brevity in your answer.  14.96. In the year 1994, what is the difference between the % of GDP in East Asia (all income levels) and % of GDP in Malaysia?
Your response must be concise. -6.57. In the year 1994, what is the difference between the % of GDP in East Asia (all income levels) and % of GDP in Mauritania?
Offer a very short reply. -19.33. In the year 1994, what is the difference between the % of GDP of Ecuador and % of GDP of Malaysia?
Your answer should be very brief. -21.53. In the year 1994, what is the difference between the % of GDP in Ecuador and % of GDP in Mauritania?
Provide a short and direct response. -34.28. In the year 1994, what is the difference between the % of GDP in Malaysia and % of GDP in Mauritania?
Your answer should be very brief. -12.75. In the year 1995, what is the difference between the % of GDP in East Asia (all income levels) and % of GDP in Ecuador?
Offer a terse response. 16.45. In the year 1995, what is the difference between the % of GDP in East Asia (all income levels) and % of GDP in Malaysia?
Make the answer very short. -6.77. In the year 1995, what is the difference between the % of GDP of East Asia (all income levels) and % of GDP of Mauritania?
Ensure brevity in your answer.  6.46. In the year 1995, what is the difference between the % of GDP of Ecuador and % of GDP of Malaysia?
Provide a short and direct response. -23.22. In the year 1995, what is the difference between the % of GDP of Ecuador and % of GDP of Mauritania?
Ensure brevity in your answer.  -9.99. In the year 1995, what is the difference between the % of GDP of Malaysia and % of GDP of Mauritania?
Keep it short and to the point. 13.22. In the year 1996, what is the difference between the % of GDP in East Asia (all income levels) and % of GDP in Ecuador?
Provide a short and direct response. 13.3. In the year 1996, what is the difference between the % of GDP in East Asia (all income levels) and % of GDP in Malaysia?
Give a very brief answer. -10.69. In the year 1996, what is the difference between the % of GDP of East Asia (all income levels) and % of GDP of Mauritania?
Provide a succinct answer. 10.45. In the year 1996, what is the difference between the % of GDP in Ecuador and % of GDP in Malaysia?
Your answer should be compact. -24. In the year 1996, what is the difference between the % of GDP in Ecuador and % of GDP in Mauritania?
Provide a short and direct response. -2.85. In the year 1996, what is the difference between the % of GDP in Malaysia and % of GDP in Mauritania?
Provide a succinct answer. 21.14. What is the ratio of the % of GDP of East Asia (all income levels) in 1989 to that in 1990?
Provide a succinct answer. 0.99. What is the ratio of the % of GDP in Ecuador in 1989 to that in 1990?
Your response must be concise. 0.9. What is the ratio of the % of GDP of Mauritania in 1989 to that in 1990?
Your answer should be compact. 2.39. What is the ratio of the % of GDP of East Asia (all income levels) in 1989 to that in 1991?
Your answer should be very brief. 0.99. What is the ratio of the % of GDP of Ecuador in 1989 to that in 1991?
Provide a short and direct response. 0.93. What is the ratio of the % of GDP of Mauritania in 1989 to that in 1991?
Provide a succinct answer. 0.79. What is the ratio of the % of GDP in Ecuador in 1989 to that in 1992?
Keep it short and to the point. 0.86. What is the ratio of the % of GDP in Malaysia in 1989 to that in 1992?
Offer a terse response. 0.93. What is the ratio of the % of GDP of Mauritania in 1989 to that in 1992?
Provide a short and direct response. 0.58. What is the ratio of the % of GDP of Ecuador in 1989 to that in 1993?
Your answer should be compact. 1.25. What is the ratio of the % of GDP of Malaysia in 1989 to that in 1993?
Provide a short and direct response. 0.88. What is the ratio of the % of GDP in Mauritania in 1989 to that in 1993?
Offer a very short reply. 0.72. What is the ratio of the % of GDP in East Asia (all income levels) in 1989 to that in 1994?
Your answer should be very brief. 1.01. What is the ratio of the % of GDP of Ecuador in 1989 to that in 1994?
Provide a succinct answer. 1.25. What is the ratio of the % of GDP in Malaysia in 1989 to that in 1994?
Make the answer very short. 0.86. What is the ratio of the % of GDP in Mauritania in 1989 to that in 1994?
Keep it short and to the point. 0.22. What is the ratio of the % of GDP in East Asia (all income levels) in 1989 to that in 1995?
Your response must be concise. 1.01. What is the ratio of the % of GDP of Ecuador in 1989 to that in 1995?
Provide a succinct answer. 1.37. What is the ratio of the % of GDP of Malaysia in 1989 to that in 1995?
Make the answer very short. 0.86. What is the ratio of the % of GDP in Mauritania in 1989 to that in 1995?
Provide a succinct answer. 0.44. What is the ratio of the % of GDP in East Asia (all income levels) in 1989 to that in 1996?
Your response must be concise. 1.03. What is the ratio of the % of GDP in Ecuador in 1989 to that in 1996?
Offer a terse response. 1.19. What is the ratio of the % of GDP in Malaysia in 1989 to that in 1996?
Your answer should be compact. 0.8. What is the ratio of the % of GDP in Mauritania in 1989 to that in 1996?
Offer a very short reply. 0.54. What is the ratio of the % of GDP of Ecuador in 1990 to that in 1991?
Offer a terse response. 1.03. What is the ratio of the % of GDP of Mauritania in 1990 to that in 1991?
Offer a terse response. 0.33. What is the ratio of the % of GDP in East Asia (all income levels) in 1990 to that in 1992?
Provide a succinct answer. 1.02. What is the ratio of the % of GDP in Ecuador in 1990 to that in 1992?
Your response must be concise. 0.96. What is the ratio of the % of GDP of Malaysia in 1990 to that in 1992?
Offer a terse response. 0.94. What is the ratio of the % of GDP in Mauritania in 1990 to that in 1992?
Provide a succinct answer. 0.24. What is the ratio of the % of GDP of East Asia (all income levels) in 1990 to that in 1993?
Ensure brevity in your answer.  1. What is the ratio of the % of GDP of Ecuador in 1990 to that in 1993?
Make the answer very short. 1.39. What is the ratio of the % of GDP in Malaysia in 1990 to that in 1993?
Make the answer very short. 0.88. What is the ratio of the % of GDP of Mauritania in 1990 to that in 1993?
Offer a terse response. 0.3. What is the ratio of the % of GDP in East Asia (all income levels) in 1990 to that in 1994?
Your answer should be compact. 1.02. What is the ratio of the % of GDP in Ecuador in 1990 to that in 1994?
Provide a short and direct response. 1.38. What is the ratio of the % of GDP of Malaysia in 1990 to that in 1994?
Your answer should be compact. 0.87. What is the ratio of the % of GDP of Mauritania in 1990 to that in 1994?
Give a very brief answer. 0.09. What is the ratio of the % of GDP of East Asia (all income levels) in 1990 to that in 1995?
Your response must be concise. 1.02. What is the ratio of the % of GDP in Ecuador in 1990 to that in 1995?
Offer a terse response. 1.52. What is the ratio of the % of GDP in Malaysia in 1990 to that in 1995?
Keep it short and to the point. 0.87. What is the ratio of the % of GDP in Mauritania in 1990 to that in 1995?
Provide a succinct answer. 0.18. What is the ratio of the % of GDP of East Asia (all income levels) in 1990 to that in 1996?
Provide a short and direct response. 1.05. What is the ratio of the % of GDP in Ecuador in 1990 to that in 1996?
Provide a succinct answer. 1.33. What is the ratio of the % of GDP in Malaysia in 1990 to that in 1996?
Give a very brief answer. 0.8. What is the ratio of the % of GDP in Mauritania in 1990 to that in 1996?
Give a very brief answer. 0.22. What is the ratio of the % of GDP of East Asia (all income levels) in 1991 to that in 1992?
Offer a terse response. 1.02. What is the ratio of the % of GDP of Ecuador in 1991 to that in 1992?
Give a very brief answer. 0.93. What is the ratio of the % of GDP in Malaysia in 1991 to that in 1992?
Offer a very short reply. 0.93. What is the ratio of the % of GDP in Mauritania in 1991 to that in 1992?
Provide a short and direct response. 0.74. What is the ratio of the % of GDP in East Asia (all income levels) in 1991 to that in 1993?
Make the answer very short. 1.01. What is the ratio of the % of GDP of Ecuador in 1991 to that in 1993?
Provide a succinct answer. 1.35. What is the ratio of the % of GDP in Malaysia in 1991 to that in 1993?
Offer a very short reply. 0.87. What is the ratio of the % of GDP of Mauritania in 1991 to that in 1993?
Give a very brief answer. 0.9. What is the ratio of the % of GDP in East Asia (all income levels) in 1991 to that in 1994?
Your answer should be compact. 1.02. What is the ratio of the % of GDP of Ecuador in 1991 to that in 1994?
Keep it short and to the point. 1.34. What is the ratio of the % of GDP in Malaysia in 1991 to that in 1994?
Ensure brevity in your answer.  0.86. What is the ratio of the % of GDP in Mauritania in 1991 to that in 1994?
Your answer should be compact. 0.28. What is the ratio of the % of GDP of East Asia (all income levels) in 1991 to that in 1995?
Keep it short and to the point. 1.02. What is the ratio of the % of GDP of Ecuador in 1991 to that in 1995?
Ensure brevity in your answer.  1.47. What is the ratio of the % of GDP of Malaysia in 1991 to that in 1995?
Provide a succinct answer. 0.86. What is the ratio of the % of GDP of Mauritania in 1991 to that in 1995?
Offer a terse response. 0.56. What is the ratio of the % of GDP of East Asia (all income levels) in 1991 to that in 1996?
Make the answer very short. 1.05. What is the ratio of the % of GDP of Ecuador in 1991 to that in 1996?
Your answer should be very brief. 1.28. What is the ratio of the % of GDP of Malaysia in 1991 to that in 1996?
Offer a terse response. 0.8. What is the ratio of the % of GDP of Mauritania in 1991 to that in 1996?
Offer a terse response. 0.68. What is the ratio of the % of GDP of Ecuador in 1992 to that in 1993?
Provide a short and direct response. 1.45. What is the ratio of the % of GDP of Malaysia in 1992 to that in 1993?
Your answer should be compact. 0.94. What is the ratio of the % of GDP in Mauritania in 1992 to that in 1993?
Offer a very short reply. 1.23. What is the ratio of the % of GDP of Ecuador in 1992 to that in 1994?
Make the answer very short. 1.45. What is the ratio of the % of GDP of Malaysia in 1992 to that in 1994?
Your answer should be compact. 0.93. What is the ratio of the % of GDP in Mauritania in 1992 to that in 1994?
Your response must be concise. 0.38. What is the ratio of the % of GDP in Ecuador in 1992 to that in 1995?
Offer a terse response. 1.58. What is the ratio of the % of GDP of Malaysia in 1992 to that in 1995?
Ensure brevity in your answer.  0.92. What is the ratio of the % of GDP of Mauritania in 1992 to that in 1995?
Your response must be concise. 0.76. What is the ratio of the % of GDP of Ecuador in 1992 to that in 1996?
Provide a succinct answer. 1.38. What is the ratio of the % of GDP of Malaysia in 1992 to that in 1996?
Keep it short and to the point. 0.86. What is the ratio of the % of GDP in Mauritania in 1992 to that in 1996?
Provide a short and direct response. 0.92. What is the ratio of the % of GDP in East Asia (all income levels) in 1993 to that in 1994?
Offer a very short reply. 1.01. What is the ratio of the % of GDP in Ecuador in 1993 to that in 1994?
Give a very brief answer. 0.99. What is the ratio of the % of GDP of Malaysia in 1993 to that in 1994?
Make the answer very short. 0.99. What is the ratio of the % of GDP of Mauritania in 1993 to that in 1994?
Provide a succinct answer. 0.31. What is the ratio of the % of GDP in East Asia (all income levels) in 1993 to that in 1995?
Your response must be concise. 1.02. What is the ratio of the % of GDP in Ecuador in 1993 to that in 1995?
Your answer should be very brief. 1.09. What is the ratio of the % of GDP of Malaysia in 1993 to that in 1995?
Give a very brief answer. 0.98. What is the ratio of the % of GDP in Mauritania in 1993 to that in 1995?
Your answer should be compact. 0.62. What is the ratio of the % of GDP in East Asia (all income levels) in 1993 to that in 1996?
Keep it short and to the point. 1.04. What is the ratio of the % of GDP in Ecuador in 1993 to that in 1996?
Provide a succinct answer. 0.95. What is the ratio of the % of GDP of Malaysia in 1993 to that in 1996?
Offer a very short reply. 0.91. What is the ratio of the % of GDP in Mauritania in 1993 to that in 1996?
Keep it short and to the point. 0.75. What is the ratio of the % of GDP in Ecuador in 1994 to that in 1995?
Make the answer very short. 1.1. What is the ratio of the % of GDP in Malaysia in 1994 to that in 1995?
Your answer should be very brief. 1. What is the ratio of the % of GDP of Mauritania in 1994 to that in 1995?
Keep it short and to the point. 1.98. What is the ratio of the % of GDP of East Asia (all income levels) in 1994 to that in 1996?
Offer a terse response. 1.03. What is the ratio of the % of GDP of Ecuador in 1994 to that in 1996?
Keep it short and to the point. 0.96. What is the ratio of the % of GDP of Malaysia in 1994 to that in 1996?
Ensure brevity in your answer.  0.92. What is the ratio of the % of GDP of Mauritania in 1994 to that in 1996?
Your answer should be very brief. 2.41. What is the ratio of the % of GDP of East Asia (all income levels) in 1995 to that in 1996?
Make the answer very short. 1.02. What is the ratio of the % of GDP of Ecuador in 1995 to that in 1996?
Offer a terse response. 0.87. What is the ratio of the % of GDP of Malaysia in 1995 to that in 1996?
Offer a very short reply. 0.93. What is the ratio of the % of GDP of Mauritania in 1995 to that in 1996?
Your answer should be compact. 1.22. What is the difference between the highest and the second highest % of GDP in East Asia (all income levels)?
Your response must be concise. 0.09. What is the difference between the highest and the second highest % of GDP of Ecuador?
Keep it short and to the point. 1.13. What is the difference between the highest and the second highest % of GDP of Malaysia?
Your response must be concise. 3.16. What is the difference between the highest and the second highest % of GDP in Mauritania?
Provide a short and direct response. 25.87. What is the difference between the highest and the lowest % of GDP of East Asia (all income levels)?
Keep it short and to the point. 1.57. What is the difference between the highest and the lowest % of GDP in Ecuador?
Provide a short and direct response. 9.64. What is the difference between the highest and the lowest % of GDP of Malaysia?
Give a very brief answer. 8.74. What is the difference between the highest and the lowest % of GDP in Mauritania?
Provide a succinct answer. 47.48. 